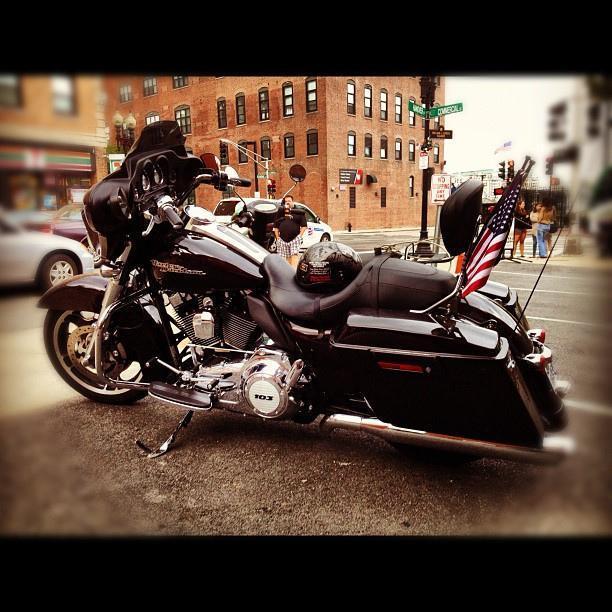How many white trucks can you see?
Give a very brief answer. 0. 